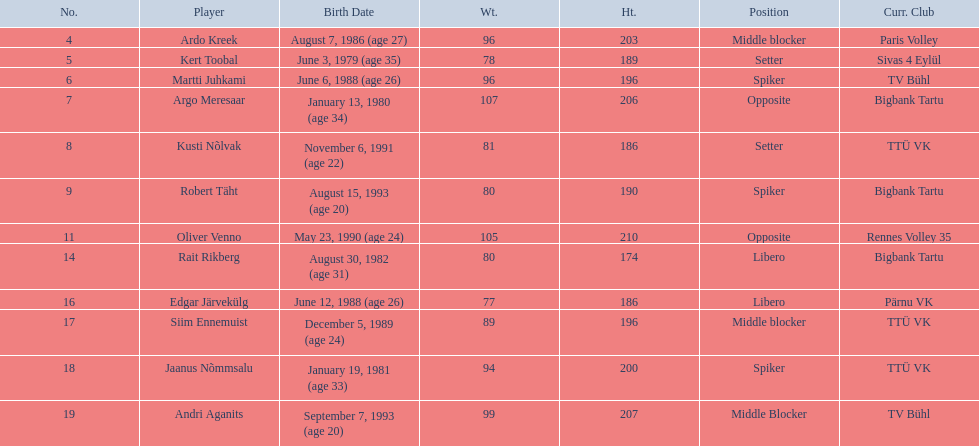What's the count of players in the middle blocker position? 3. 